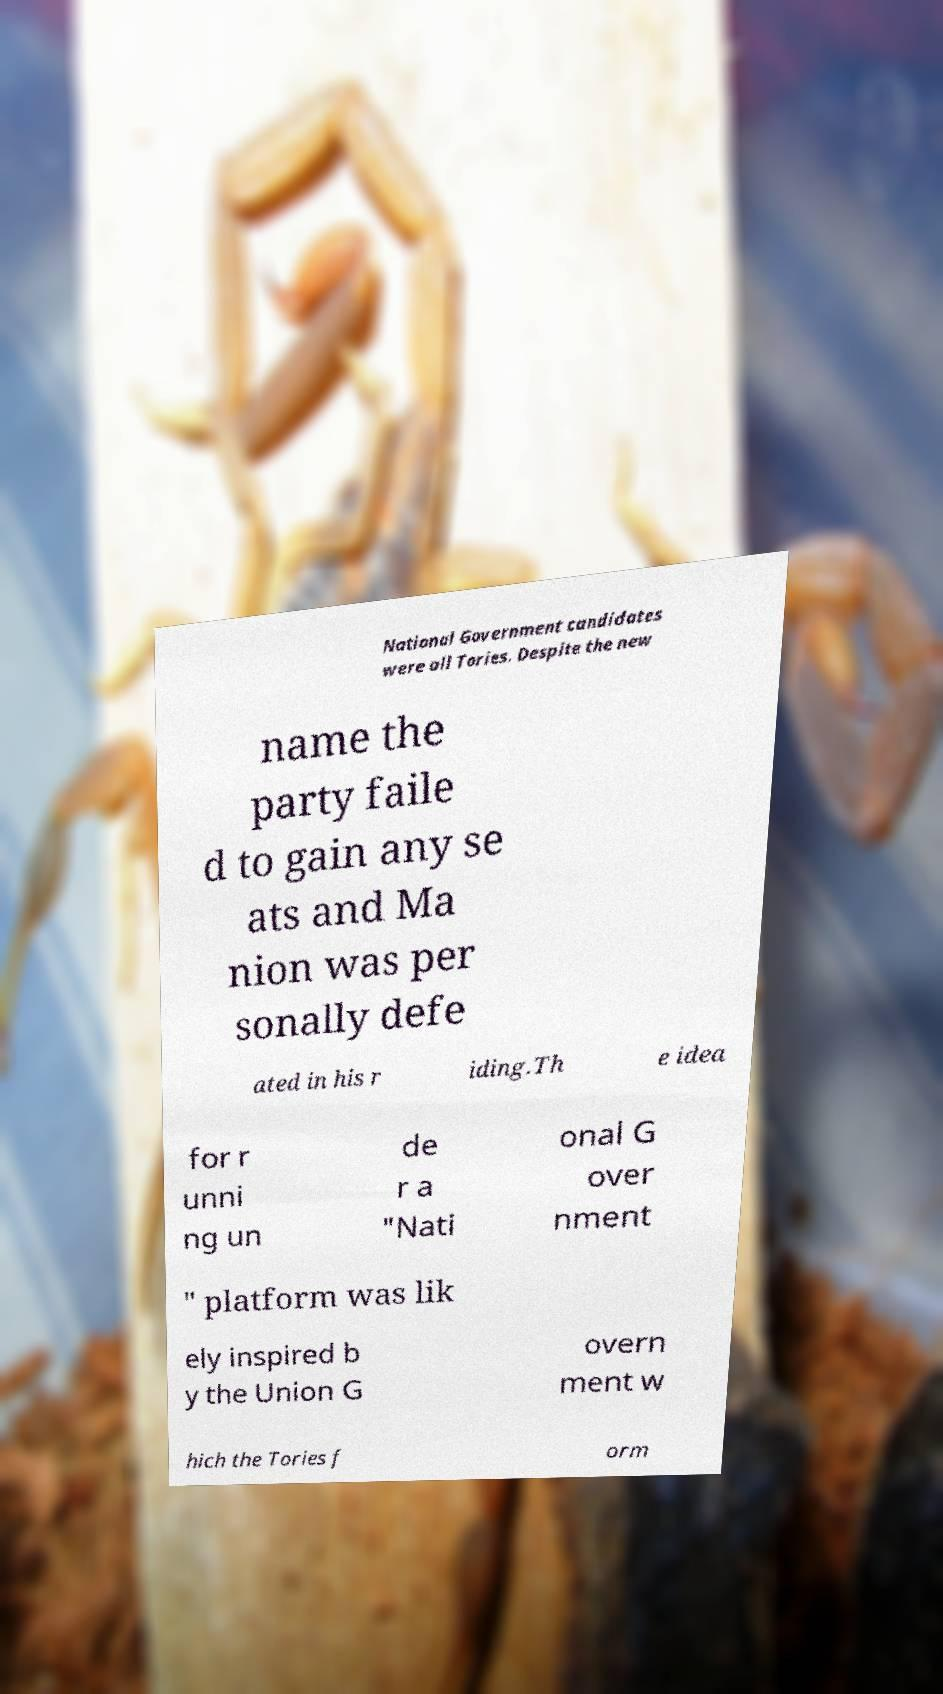Can you accurately transcribe the text from the provided image for me? National Government candidates were all Tories. Despite the new name the party faile d to gain any se ats and Ma nion was per sonally defe ated in his r iding.Th e idea for r unni ng un de r a "Nati onal G over nment " platform was lik ely inspired b y the Union G overn ment w hich the Tories f orm 